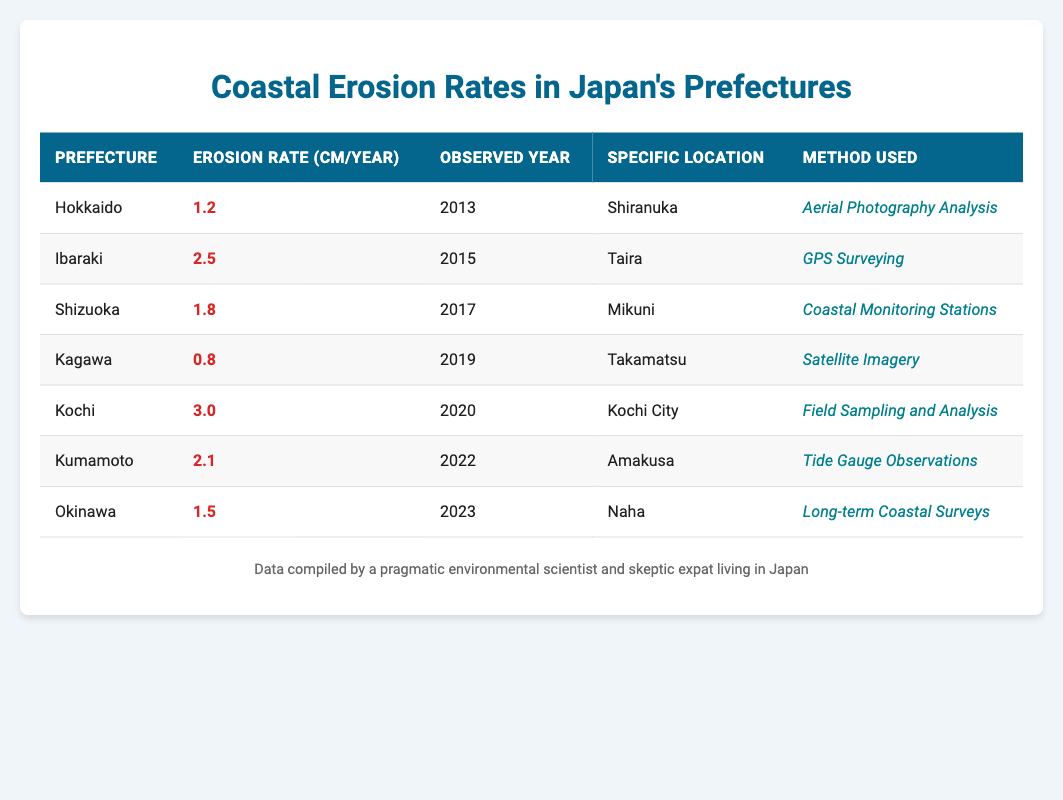What is the highest coastal erosion rate reported in the table? The table lists the coastal erosion rates for several prefectures. By scanning through the "Erosion Rate (cm/year)" column, I find that Kochi has the highest rate of 3.0 cm/year.
Answer: 3.0 cm/year Which prefecture has the lowest coastal erosion rate? Looking at the "Erosion Rate (cm/year)" column, Kagawa has the lowest reported erosion rate at 0.8 cm/year.
Answer: Kagawa What is the average coastal erosion rate for the years 2013 to 2023? First, I sum the erosion rates: 1.2 + 2.5 + 1.8 + 0.8 + 3.0 + 2.1 + 1.5 = 13.9 cm/year. Then, I divide by the number of entries (7) to find the average: 13.9 / 7 = 1.9857, which rounds to approximately 2.0 cm/year.
Answer: 2.0 cm/year Did any prefecture report an erosion rate higher than 2.0 cm/year? Checking the "Erosion Rate (cm/year)" column for values greater than 2.0 cm/year, I see that both Kochi (3.0 cm/year) and Ibaraki (2.5 cm/year) meet this criterion. Thus, the answer is yes.
Answer: Yes In which year was the coastal erosion rate for Kumamoto observed? The "Observed Year" column shows that the rate for Kumamoto was recorded in 2022.
Answer: 2022 Which method was used to calculate the erosion rate in Shizuoka? By reviewing the "Method Used" column for Shizuoka, it indicates that the erosion rate was calculated using "Coastal Monitoring Stations."
Answer: Coastal Monitoring Stations If I compare the erosion rates of Hokkaido and Okinawa, which one has a greater rate? Hokkaido’s rate is 1.2 cm/year and Okinawa’s is 1.5 cm/year. Since 1.5 is greater than 1.2, Okinawa has the greater coastal erosion rate.
Answer: Okinawa What are the specific locations for the highest and lowest recorded erosion rates? Kochi has the highest rate (3.0 cm/year) recorded in Kochi City, while Kagawa has the lowest rate (0.8 cm/year) observed in Takamatsu.
Answer: Kochi City and Takamatsu 